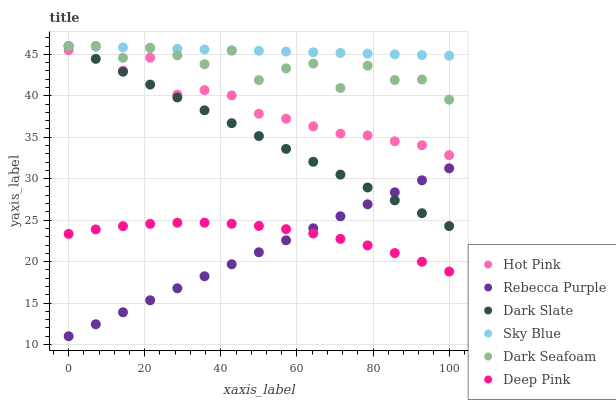Does Rebecca Purple have the minimum area under the curve?
Answer yes or no. Yes. Does Sky Blue have the maximum area under the curve?
Answer yes or no. Yes. Does Hot Pink have the minimum area under the curve?
Answer yes or no. No. Does Hot Pink have the maximum area under the curve?
Answer yes or no. No. Is Rebecca Purple the smoothest?
Answer yes or no. Yes. Is Dark Seafoam the roughest?
Answer yes or no. Yes. Is Hot Pink the smoothest?
Answer yes or no. No. Is Hot Pink the roughest?
Answer yes or no. No. Does Rebecca Purple have the lowest value?
Answer yes or no. Yes. Does Hot Pink have the lowest value?
Answer yes or no. No. Does Sky Blue have the highest value?
Answer yes or no. Yes. Does Rebecca Purple have the highest value?
Answer yes or no. No. Is Deep Pink less than Hot Pink?
Answer yes or no. Yes. Is Dark Seafoam greater than Deep Pink?
Answer yes or no. Yes. Does Dark Seafoam intersect Dark Slate?
Answer yes or no. Yes. Is Dark Seafoam less than Dark Slate?
Answer yes or no. No. Is Dark Seafoam greater than Dark Slate?
Answer yes or no. No. Does Deep Pink intersect Hot Pink?
Answer yes or no. No. 